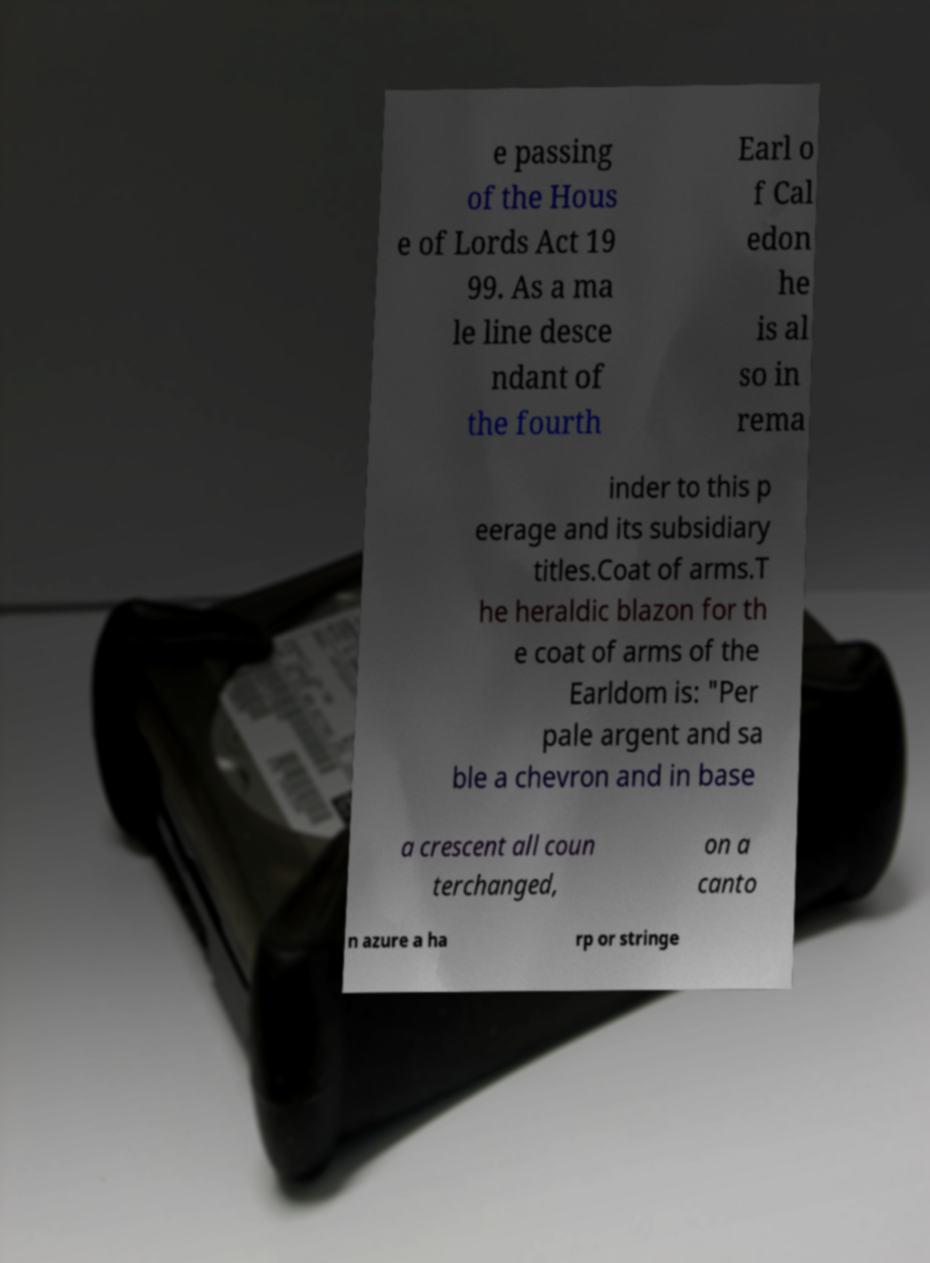Please identify and transcribe the text found in this image. e passing of the Hous e of Lords Act 19 99. As a ma le line desce ndant of the fourth Earl o f Cal edon he is al so in rema inder to this p eerage and its subsidiary titles.Coat of arms.T he heraldic blazon for th e coat of arms of the Earldom is: "Per pale argent and sa ble a chevron and in base a crescent all coun terchanged, on a canto n azure a ha rp or stringe 